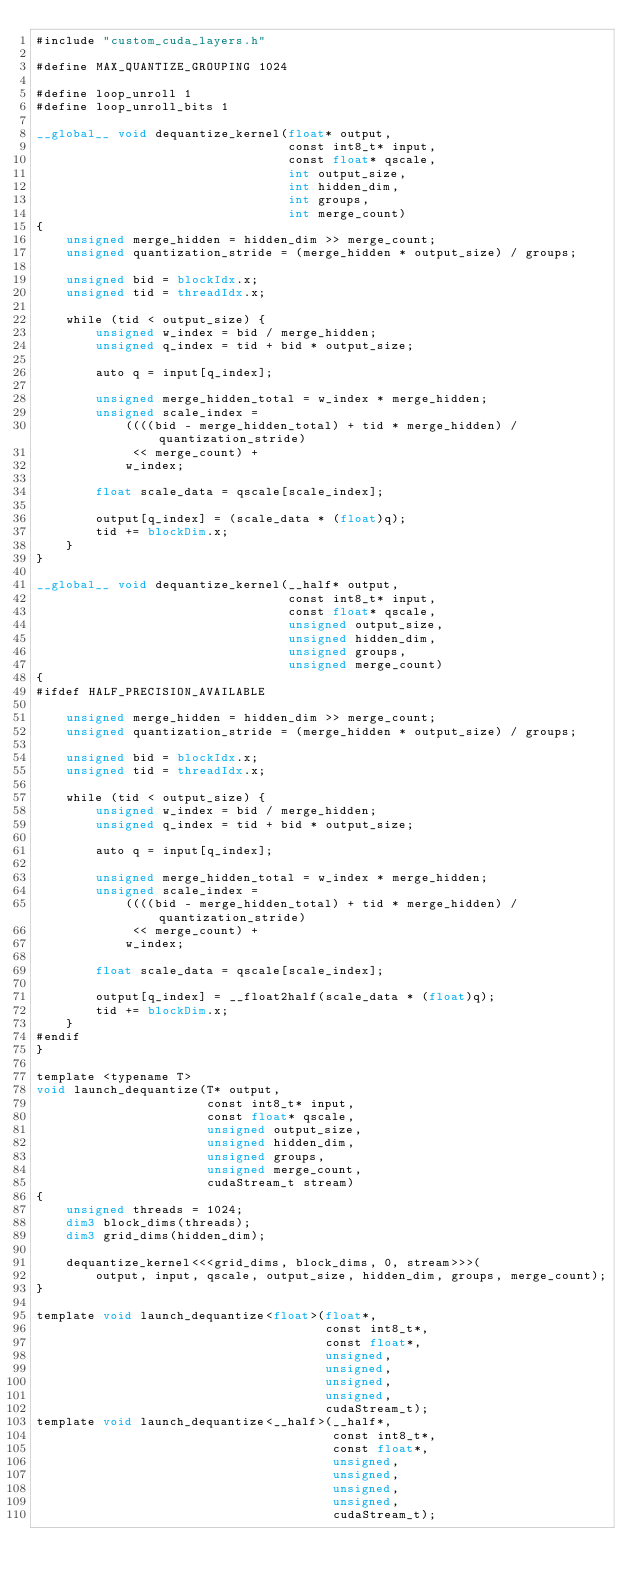<code> <loc_0><loc_0><loc_500><loc_500><_Cuda_>#include "custom_cuda_layers.h"

#define MAX_QUANTIZE_GROUPING 1024

#define loop_unroll 1
#define loop_unroll_bits 1

__global__ void dequantize_kernel(float* output,
                                  const int8_t* input,
                                  const float* qscale,
                                  int output_size,
                                  int hidden_dim,
                                  int groups,
                                  int merge_count)
{
    unsigned merge_hidden = hidden_dim >> merge_count;
    unsigned quantization_stride = (merge_hidden * output_size) / groups;

    unsigned bid = blockIdx.x;
    unsigned tid = threadIdx.x;

    while (tid < output_size) {
        unsigned w_index = bid / merge_hidden;
        unsigned q_index = tid + bid * output_size;

        auto q = input[q_index];

        unsigned merge_hidden_total = w_index * merge_hidden;
        unsigned scale_index =
            ((((bid - merge_hidden_total) + tid * merge_hidden) / quantization_stride)
             << merge_count) +
            w_index;

        float scale_data = qscale[scale_index];

        output[q_index] = (scale_data * (float)q);
        tid += blockDim.x;
    }
}

__global__ void dequantize_kernel(__half* output,
                                  const int8_t* input,
                                  const float* qscale,
                                  unsigned output_size,
                                  unsigned hidden_dim,
                                  unsigned groups,
                                  unsigned merge_count)
{
#ifdef HALF_PRECISION_AVAILABLE

    unsigned merge_hidden = hidden_dim >> merge_count;
    unsigned quantization_stride = (merge_hidden * output_size) / groups;

    unsigned bid = blockIdx.x;
    unsigned tid = threadIdx.x;

    while (tid < output_size) {
        unsigned w_index = bid / merge_hidden;
        unsigned q_index = tid + bid * output_size;

        auto q = input[q_index];

        unsigned merge_hidden_total = w_index * merge_hidden;
        unsigned scale_index =
            ((((bid - merge_hidden_total) + tid * merge_hidden) / quantization_stride)
             << merge_count) +
            w_index;

        float scale_data = qscale[scale_index];

        output[q_index] = __float2half(scale_data * (float)q);
        tid += blockDim.x;
    }
#endif
}

template <typename T>
void launch_dequantize(T* output,
                       const int8_t* input,
                       const float* qscale,
                       unsigned output_size,
                       unsigned hidden_dim,
                       unsigned groups,
                       unsigned merge_count,
                       cudaStream_t stream)
{
    unsigned threads = 1024;
    dim3 block_dims(threads);
    dim3 grid_dims(hidden_dim);

    dequantize_kernel<<<grid_dims, block_dims, 0, stream>>>(
        output, input, qscale, output_size, hidden_dim, groups, merge_count);
}

template void launch_dequantize<float>(float*,
                                       const int8_t*,
                                       const float*,
                                       unsigned,
                                       unsigned,
                                       unsigned,
                                       unsigned,
                                       cudaStream_t);
template void launch_dequantize<__half>(__half*,
                                        const int8_t*,
                                        const float*,
                                        unsigned,
                                        unsigned,
                                        unsigned,
                                        unsigned,
                                        cudaStream_t);
</code> 